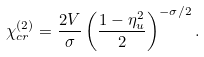<formula> <loc_0><loc_0><loc_500><loc_500>\chi _ { c r } ^ { ( 2 ) } = \frac { 2 V } { \sigma } \left ( \frac { 1 - \eta _ { u } ^ { 2 } } { 2 } \right ) ^ { - \sigma / 2 } .</formula> 